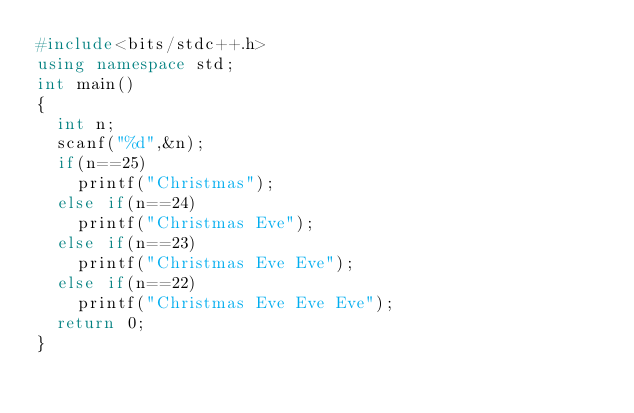<code> <loc_0><loc_0><loc_500><loc_500><_C++_>#include<bits/stdc++.h>
using namespace std;
int main()
{
  int n;
  scanf("%d",&n);
  if(n==25)
    printf("Christmas");
  else if(n==24)
    printf("Christmas Eve");
  else if(n==23)
    printf("Christmas Eve Eve");
  else if(n==22)
    printf("Christmas Eve Eve Eve");
  return 0;
}  </code> 